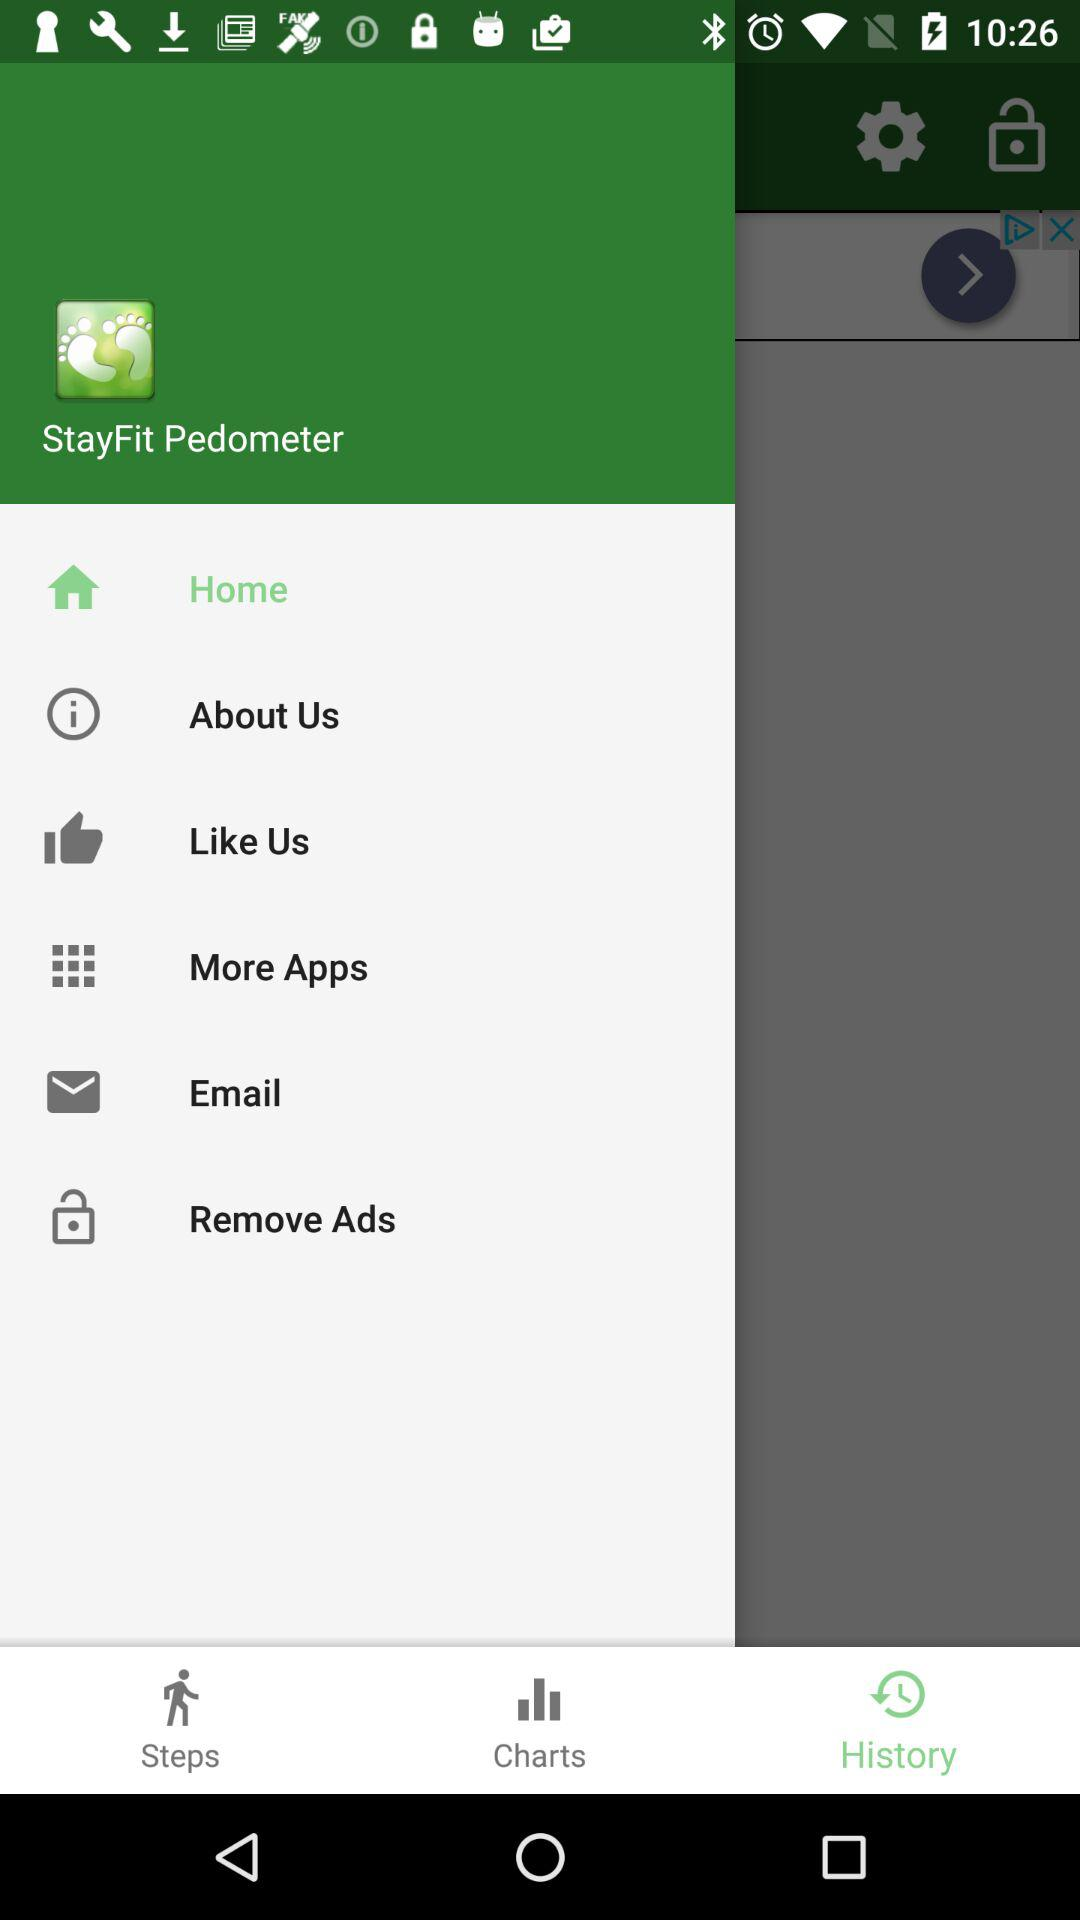Which tab is selected? The selected tab is "History". 